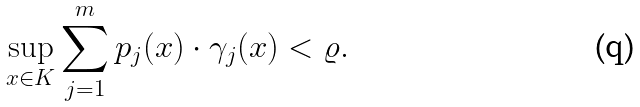<formula> <loc_0><loc_0><loc_500><loc_500>\sup _ { x \in K } \sum _ { j = 1 } ^ { m } p _ { j } ( x ) \cdot \gamma _ { j } ( x ) < \varrho .</formula> 